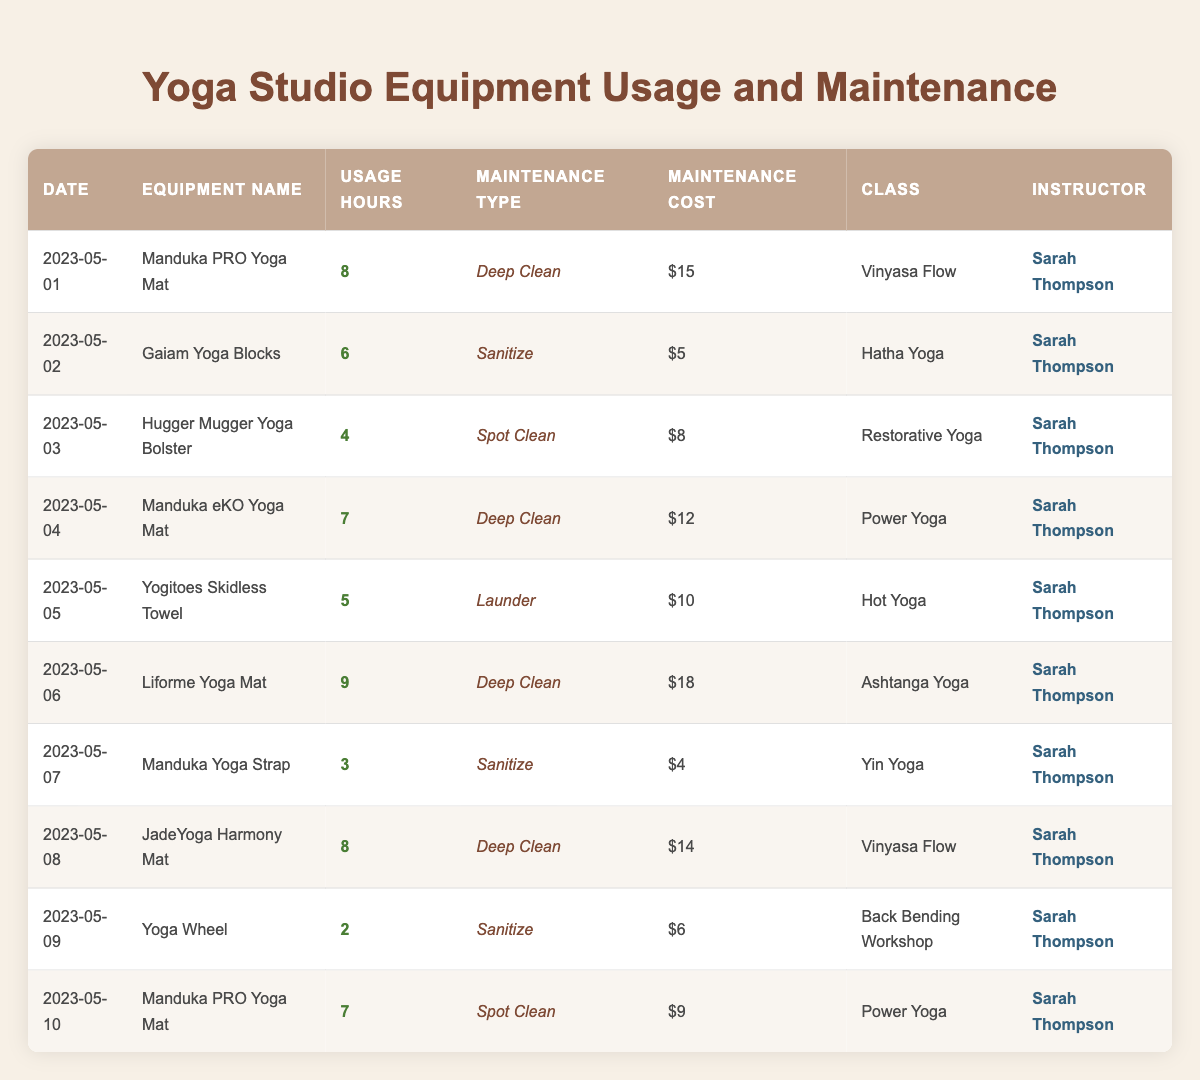What was the highest maintenance cost recorded? By examining the 'Maintenance Cost' column, the highest number is 18, associated with the 'Liforme Yoga Mat' on 2023-05-06.
Answer: 18 Which equipment type was used the most hours on a single day? The equipment with the highest usage hours on a single day is the 'Liforme Yoga Mat' with 9 usage hours on 2023-05-06.
Answer: Liforme Yoga Mat How many classes were taught with the Manduka PRO Yoga Mat? The Manduka PRO Yoga Mat appears twice: on 2023-05-01 and 2023-05-10, indicating it was used in two classes.
Answer: 2 What is the average usage hours of all equipment? To find the average, we sum the usage hours (8 + 6 + 4 + 7 + 5 + 9 + 3 + 8 + 2 + 7 = 59) and divide by the total number of records (10). Thus, the average usage hours are 59 divided by 10 equals 5.9.
Answer: 5.9 Did the instructor Sarah Thompson use any equipment for less than 4 hours? Reviewing the table shows that the 'Yoga Wheel' had 2 usage hours on 2023-05-09, which is less than 4 hours.
Answer: Yes Which maintenance type was used most frequently? By reviewing the maintenance type column, it can be noted that 'Deep Clean' was listed 4 times, which is more than any other maintenance type.
Answer: Deep Clean What are the maintenance costs for the Yoga Wheel? Looking at the row for the 'Yoga Wheel', the maintenance cost is recorded as 6 on 2023-05-09.
Answer: 6 How many yoga classes were associated with cleaning types other than 'Deep Clean'? The maintenance types other than 'Deep Clean' include 'Sanitize', 'Spot Clean', and 'Launder'. Counting those instances in the table yields a total of 6 occurrences.
Answer: 6 What was the total cost for maintenance types involving 'Sanitize'? The maintenance costs for 'Sanitize' are 5 (Gaiam Yoga Blocks), 4 (Manduka Yoga Strap), and 6 (Yoga Wheel). Adding these amounts gives a total of 5 + 4 + 6 = 15.
Answer: 15 